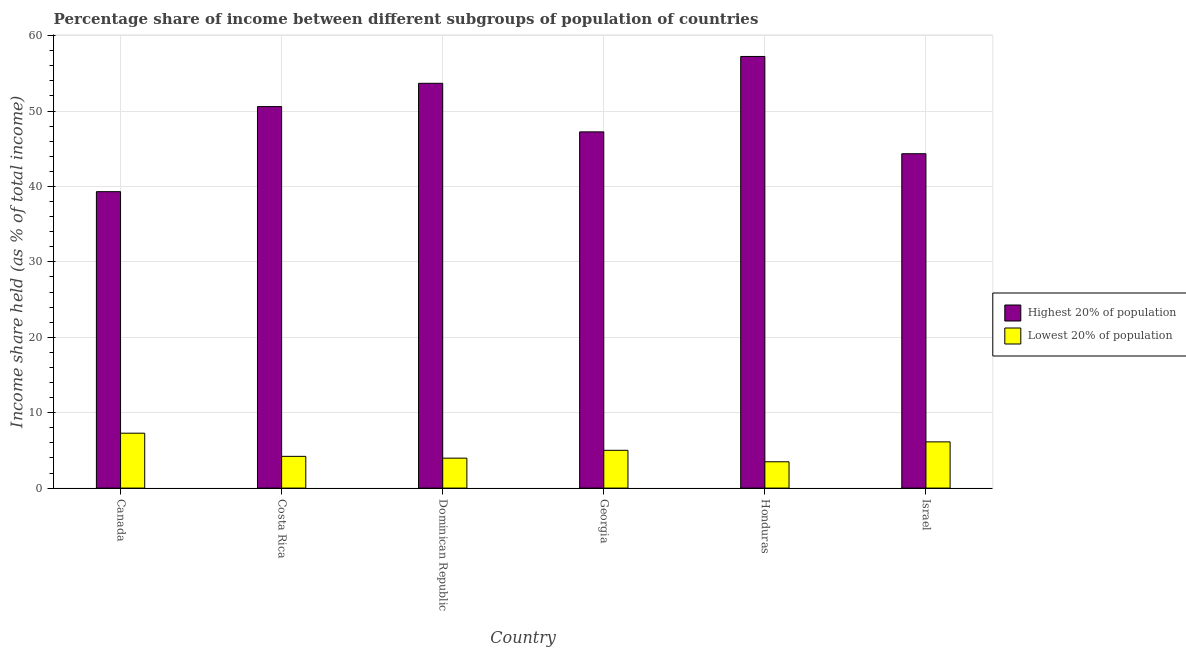How many different coloured bars are there?
Offer a very short reply. 2. How many groups of bars are there?
Give a very brief answer. 6. Are the number of bars per tick equal to the number of legend labels?
Provide a short and direct response. Yes. Are the number of bars on each tick of the X-axis equal?
Offer a very short reply. Yes. How many bars are there on the 4th tick from the right?
Offer a terse response. 2. What is the label of the 3rd group of bars from the left?
Provide a short and direct response. Dominican Republic. In how many cases, is the number of bars for a given country not equal to the number of legend labels?
Keep it short and to the point. 0. What is the income share held by highest 20% of the population in Costa Rica?
Provide a short and direct response. 50.59. Across all countries, what is the maximum income share held by lowest 20% of the population?
Keep it short and to the point. 7.28. Across all countries, what is the minimum income share held by lowest 20% of the population?
Give a very brief answer. 3.49. In which country was the income share held by lowest 20% of the population minimum?
Make the answer very short. Honduras. What is the total income share held by lowest 20% of the population in the graph?
Offer a very short reply. 30.09. What is the difference between the income share held by highest 20% of the population in Costa Rica and that in Honduras?
Give a very brief answer. -6.65. What is the difference between the income share held by lowest 20% of the population in Canada and the income share held by highest 20% of the population in Costa Rica?
Your answer should be very brief. -43.31. What is the average income share held by highest 20% of the population per country?
Give a very brief answer. 48.73. What is the difference between the income share held by lowest 20% of the population and income share held by highest 20% of the population in Honduras?
Provide a short and direct response. -53.75. In how many countries, is the income share held by lowest 20% of the population greater than 28 %?
Offer a very short reply. 0. What is the ratio of the income share held by lowest 20% of the population in Costa Rica to that in Honduras?
Make the answer very short. 1.21. Is the income share held by lowest 20% of the population in Canada less than that in Dominican Republic?
Your response must be concise. No. Is the difference between the income share held by highest 20% of the population in Canada and Georgia greater than the difference between the income share held by lowest 20% of the population in Canada and Georgia?
Your response must be concise. No. What is the difference between the highest and the second highest income share held by highest 20% of the population?
Offer a very short reply. 3.56. What is the difference between the highest and the lowest income share held by highest 20% of the population?
Give a very brief answer. 17.93. What does the 2nd bar from the left in Israel represents?
Provide a succinct answer. Lowest 20% of population. What does the 1st bar from the right in Georgia represents?
Make the answer very short. Lowest 20% of population. How many bars are there?
Offer a very short reply. 12. How many countries are there in the graph?
Your answer should be very brief. 6. What is the difference between two consecutive major ticks on the Y-axis?
Keep it short and to the point. 10. Does the graph contain grids?
Your response must be concise. Yes. How are the legend labels stacked?
Offer a terse response. Vertical. What is the title of the graph?
Make the answer very short. Percentage share of income between different subgroups of population of countries. What is the label or title of the Y-axis?
Offer a very short reply. Income share held (as % of total income). What is the Income share held (as % of total income) in Highest 20% of population in Canada?
Offer a terse response. 39.31. What is the Income share held (as % of total income) of Lowest 20% of population in Canada?
Your answer should be very brief. 7.28. What is the Income share held (as % of total income) of Highest 20% of population in Costa Rica?
Provide a short and direct response. 50.59. What is the Income share held (as % of total income) in Lowest 20% of population in Costa Rica?
Give a very brief answer. 4.21. What is the Income share held (as % of total income) in Highest 20% of population in Dominican Republic?
Your response must be concise. 53.68. What is the Income share held (as % of total income) of Lowest 20% of population in Dominican Republic?
Your answer should be compact. 3.97. What is the Income share held (as % of total income) of Highest 20% of population in Georgia?
Offer a very short reply. 47.24. What is the Income share held (as % of total income) of Lowest 20% of population in Georgia?
Your answer should be very brief. 5.01. What is the Income share held (as % of total income) of Highest 20% of population in Honduras?
Offer a terse response. 57.24. What is the Income share held (as % of total income) in Lowest 20% of population in Honduras?
Your answer should be compact. 3.49. What is the Income share held (as % of total income) of Highest 20% of population in Israel?
Provide a short and direct response. 44.34. What is the Income share held (as % of total income) of Lowest 20% of population in Israel?
Keep it short and to the point. 6.13. Across all countries, what is the maximum Income share held (as % of total income) of Highest 20% of population?
Ensure brevity in your answer.  57.24. Across all countries, what is the maximum Income share held (as % of total income) in Lowest 20% of population?
Make the answer very short. 7.28. Across all countries, what is the minimum Income share held (as % of total income) in Highest 20% of population?
Offer a very short reply. 39.31. Across all countries, what is the minimum Income share held (as % of total income) in Lowest 20% of population?
Give a very brief answer. 3.49. What is the total Income share held (as % of total income) of Highest 20% of population in the graph?
Make the answer very short. 292.4. What is the total Income share held (as % of total income) of Lowest 20% of population in the graph?
Your answer should be compact. 30.09. What is the difference between the Income share held (as % of total income) of Highest 20% of population in Canada and that in Costa Rica?
Provide a short and direct response. -11.28. What is the difference between the Income share held (as % of total income) of Lowest 20% of population in Canada and that in Costa Rica?
Make the answer very short. 3.07. What is the difference between the Income share held (as % of total income) of Highest 20% of population in Canada and that in Dominican Republic?
Provide a succinct answer. -14.37. What is the difference between the Income share held (as % of total income) in Lowest 20% of population in Canada and that in Dominican Republic?
Your answer should be compact. 3.31. What is the difference between the Income share held (as % of total income) in Highest 20% of population in Canada and that in Georgia?
Keep it short and to the point. -7.93. What is the difference between the Income share held (as % of total income) of Lowest 20% of population in Canada and that in Georgia?
Ensure brevity in your answer.  2.27. What is the difference between the Income share held (as % of total income) of Highest 20% of population in Canada and that in Honduras?
Offer a very short reply. -17.93. What is the difference between the Income share held (as % of total income) in Lowest 20% of population in Canada and that in Honduras?
Your response must be concise. 3.79. What is the difference between the Income share held (as % of total income) in Highest 20% of population in Canada and that in Israel?
Provide a short and direct response. -5.03. What is the difference between the Income share held (as % of total income) in Lowest 20% of population in Canada and that in Israel?
Make the answer very short. 1.15. What is the difference between the Income share held (as % of total income) of Highest 20% of population in Costa Rica and that in Dominican Republic?
Your response must be concise. -3.09. What is the difference between the Income share held (as % of total income) of Lowest 20% of population in Costa Rica and that in Dominican Republic?
Make the answer very short. 0.24. What is the difference between the Income share held (as % of total income) in Highest 20% of population in Costa Rica and that in Georgia?
Offer a terse response. 3.35. What is the difference between the Income share held (as % of total income) of Highest 20% of population in Costa Rica and that in Honduras?
Give a very brief answer. -6.65. What is the difference between the Income share held (as % of total income) of Lowest 20% of population in Costa Rica and that in Honduras?
Keep it short and to the point. 0.72. What is the difference between the Income share held (as % of total income) of Highest 20% of population in Costa Rica and that in Israel?
Keep it short and to the point. 6.25. What is the difference between the Income share held (as % of total income) of Lowest 20% of population in Costa Rica and that in Israel?
Provide a short and direct response. -1.92. What is the difference between the Income share held (as % of total income) of Highest 20% of population in Dominican Republic and that in Georgia?
Make the answer very short. 6.44. What is the difference between the Income share held (as % of total income) in Lowest 20% of population in Dominican Republic and that in Georgia?
Give a very brief answer. -1.04. What is the difference between the Income share held (as % of total income) in Highest 20% of population in Dominican Republic and that in Honduras?
Your answer should be very brief. -3.56. What is the difference between the Income share held (as % of total income) of Lowest 20% of population in Dominican Republic and that in Honduras?
Offer a very short reply. 0.48. What is the difference between the Income share held (as % of total income) in Highest 20% of population in Dominican Republic and that in Israel?
Your response must be concise. 9.34. What is the difference between the Income share held (as % of total income) in Lowest 20% of population in Dominican Republic and that in Israel?
Your answer should be very brief. -2.16. What is the difference between the Income share held (as % of total income) in Highest 20% of population in Georgia and that in Honduras?
Your answer should be very brief. -10. What is the difference between the Income share held (as % of total income) of Lowest 20% of population in Georgia and that in Honduras?
Provide a succinct answer. 1.52. What is the difference between the Income share held (as % of total income) in Highest 20% of population in Georgia and that in Israel?
Make the answer very short. 2.9. What is the difference between the Income share held (as % of total income) in Lowest 20% of population in Georgia and that in Israel?
Give a very brief answer. -1.12. What is the difference between the Income share held (as % of total income) in Highest 20% of population in Honduras and that in Israel?
Your answer should be compact. 12.9. What is the difference between the Income share held (as % of total income) of Lowest 20% of population in Honduras and that in Israel?
Ensure brevity in your answer.  -2.64. What is the difference between the Income share held (as % of total income) in Highest 20% of population in Canada and the Income share held (as % of total income) in Lowest 20% of population in Costa Rica?
Your response must be concise. 35.1. What is the difference between the Income share held (as % of total income) in Highest 20% of population in Canada and the Income share held (as % of total income) in Lowest 20% of population in Dominican Republic?
Give a very brief answer. 35.34. What is the difference between the Income share held (as % of total income) of Highest 20% of population in Canada and the Income share held (as % of total income) of Lowest 20% of population in Georgia?
Your response must be concise. 34.3. What is the difference between the Income share held (as % of total income) in Highest 20% of population in Canada and the Income share held (as % of total income) in Lowest 20% of population in Honduras?
Offer a very short reply. 35.82. What is the difference between the Income share held (as % of total income) in Highest 20% of population in Canada and the Income share held (as % of total income) in Lowest 20% of population in Israel?
Offer a very short reply. 33.18. What is the difference between the Income share held (as % of total income) in Highest 20% of population in Costa Rica and the Income share held (as % of total income) in Lowest 20% of population in Dominican Republic?
Your answer should be compact. 46.62. What is the difference between the Income share held (as % of total income) of Highest 20% of population in Costa Rica and the Income share held (as % of total income) of Lowest 20% of population in Georgia?
Your answer should be very brief. 45.58. What is the difference between the Income share held (as % of total income) in Highest 20% of population in Costa Rica and the Income share held (as % of total income) in Lowest 20% of population in Honduras?
Your answer should be compact. 47.1. What is the difference between the Income share held (as % of total income) of Highest 20% of population in Costa Rica and the Income share held (as % of total income) of Lowest 20% of population in Israel?
Provide a short and direct response. 44.46. What is the difference between the Income share held (as % of total income) of Highest 20% of population in Dominican Republic and the Income share held (as % of total income) of Lowest 20% of population in Georgia?
Give a very brief answer. 48.67. What is the difference between the Income share held (as % of total income) of Highest 20% of population in Dominican Republic and the Income share held (as % of total income) of Lowest 20% of population in Honduras?
Provide a short and direct response. 50.19. What is the difference between the Income share held (as % of total income) of Highest 20% of population in Dominican Republic and the Income share held (as % of total income) of Lowest 20% of population in Israel?
Provide a succinct answer. 47.55. What is the difference between the Income share held (as % of total income) in Highest 20% of population in Georgia and the Income share held (as % of total income) in Lowest 20% of population in Honduras?
Offer a very short reply. 43.75. What is the difference between the Income share held (as % of total income) in Highest 20% of population in Georgia and the Income share held (as % of total income) in Lowest 20% of population in Israel?
Keep it short and to the point. 41.11. What is the difference between the Income share held (as % of total income) in Highest 20% of population in Honduras and the Income share held (as % of total income) in Lowest 20% of population in Israel?
Ensure brevity in your answer.  51.11. What is the average Income share held (as % of total income) in Highest 20% of population per country?
Provide a short and direct response. 48.73. What is the average Income share held (as % of total income) in Lowest 20% of population per country?
Offer a terse response. 5.01. What is the difference between the Income share held (as % of total income) in Highest 20% of population and Income share held (as % of total income) in Lowest 20% of population in Canada?
Ensure brevity in your answer.  32.03. What is the difference between the Income share held (as % of total income) of Highest 20% of population and Income share held (as % of total income) of Lowest 20% of population in Costa Rica?
Your answer should be compact. 46.38. What is the difference between the Income share held (as % of total income) of Highest 20% of population and Income share held (as % of total income) of Lowest 20% of population in Dominican Republic?
Your answer should be very brief. 49.71. What is the difference between the Income share held (as % of total income) in Highest 20% of population and Income share held (as % of total income) in Lowest 20% of population in Georgia?
Provide a succinct answer. 42.23. What is the difference between the Income share held (as % of total income) in Highest 20% of population and Income share held (as % of total income) in Lowest 20% of population in Honduras?
Provide a short and direct response. 53.75. What is the difference between the Income share held (as % of total income) of Highest 20% of population and Income share held (as % of total income) of Lowest 20% of population in Israel?
Your answer should be compact. 38.21. What is the ratio of the Income share held (as % of total income) of Highest 20% of population in Canada to that in Costa Rica?
Offer a very short reply. 0.78. What is the ratio of the Income share held (as % of total income) of Lowest 20% of population in Canada to that in Costa Rica?
Your response must be concise. 1.73. What is the ratio of the Income share held (as % of total income) in Highest 20% of population in Canada to that in Dominican Republic?
Provide a short and direct response. 0.73. What is the ratio of the Income share held (as % of total income) in Lowest 20% of population in Canada to that in Dominican Republic?
Provide a short and direct response. 1.83. What is the ratio of the Income share held (as % of total income) in Highest 20% of population in Canada to that in Georgia?
Give a very brief answer. 0.83. What is the ratio of the Income share held (as % of total income) of Lowest 20% of population in Canada to that in Georgia?
Your response must be concise. 1.45. What is the ratio of the Income share held (as % of total income) of Highest 20% of population in Canada to that in Honduras?
Offer a terse response. 0.69. What is the ratio of the Income share held (as % of total income) of Lowest 20% of population in Canada to that in Honduras?
Ensure brevity in your answer.  2.09. What is the ratio of the Income share held (as % of total income) in Highest 20% of population in Canada to that in Israel?
Ensure brevity in your answer.  0.89. What is the ratio of the Income share held (as % of total income) of Lowest 20% of population in Canada to that in Israel?
Provide a succinct answer. 1.19. What is the ratio of the Income share held (as % of total income) of Highest 20% of population in Costa Rica to that in Dominican Republic?
Provide a succinct answer. 0.94. What is the ratio of the Income share held (as % of total income) of Lowest 20% of population in Costa Rica to that in Dominican Republic?
Provide a succinct answer. 1.06. What is the ratio of the Income share held (as % of total income) in Highest 20% of population in Costa Rica to that in Georgia?
Keep it short and to the point. 1.07. What is the ratio of the Income share held (as % of total income) in Lowest 20% of population in Costa Rica to that in Georgia?
Offer a very short reply. 0.84. What is the ratio of the Income share held (as % of total income) of Highest 20% of population in Costa Rica to that in Honduras?
Keep it short and to the point. 0.88. What is the ratio of the Income share held (as % of total income) of Lowest 20% of population in Costa Rica to that in Honduras?
Offer a terse response. 1.21. What is the ratio of the Income share held (as % of total income) in Highest 20% of population in Costa Rica to that in Israel?
Provide a succinct answer. 1.14. What is the ratio of the Income share held (as % of total income) in Lowest 20% of population in Costa Rica to that in Israel?
Your answer should be very brief. 0.69. What is the ratio of the Income share held (as % of total income) of Highest 20% of population in Dominican Republic to that in Georgia?
Your answer should be very brief. 1.14. What is the ratio of the Income share held (as % of total income) of Lowest 20% of population in Dominican Republic to that in Georgia?
Your answer should be very brief. 0.79. What is the ratio of the Income share held (as % of total income) in Highest 20% of population in Dominican Republic to that in Honduras?
Offer a very short reply. 0.94. What is the ratio of the Income share held (as % of total income) in Lowest 20% of population in Dominican Republic to that in Honduras?
Provide a short and direct response. 1.14. What is the ratio of the Income share held (as % of total income) in Highest 20% of population in Dominican Republic to that in Israel?
Make the answer very short. 1.21. What is the ratio of the Income share held (as % of total income) in Lowest 20% of population in Dominican Republic to that in Israel?
Offer a very short reply. 0.65. What is the ratio of the Income share held (as % of total income) of Highest 20% of population in Georgia to that in Honduras?
Your answer should be compact. 0.83. What is the ratio of the Income share held (as % of total income) of Lowest 20% of population in Georgia to that in Honduras?
Offer a terse response. 1.44. What is the ratio of the Income share held (as % of total income) of Highest 20% of population in Georgia to that in Israel?
Make the answer very short. 1.07. What is the ratio of the Income share held (as % of total income) of Lowest 20% of population in Georgia to that in Israel?
Your response must be concise. 0.82. What is the ratio of the Income share held (as % of total income) of Highest 20% of population in Honduras to that in Israel?
Provide a succinct answer. 1.29. What is the ratio of the Income share held (as % of total income) in Lowest 20% of population in Honduras to that in Israel?
Make the answer very short. 0.57. What is the difference between the highest and the second highest Income share held (as % of total income) of Highest 20% of population?
Your answer should be very brief. 3.56. What is the difference between the highest and the second highest Income share held (as % of total income) in Lowest 20% of population?
Your answer should be very brief. 1.15. What is the difference between the highest and the lowest Income share held (as % of total income) of Highest 20% of population?
Give a very brief answer. 17.93. What is the difference between the highest and the lowest Income share held (as % of total income) in Lowest 20% of population?
Your response must be concise. 3.79. 